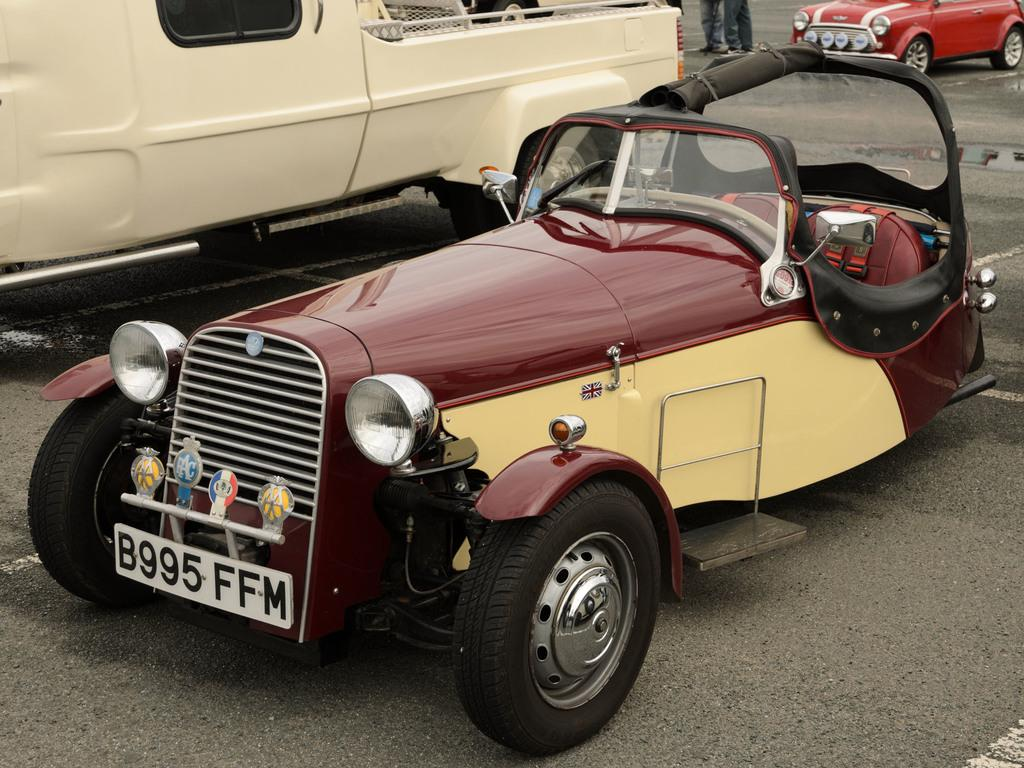What can be seen on the road in the image? There are vehicles on the road in the image. Can you describe the people in the image? The legs of persons are visible at the top of the image. Where is the faucet located in the image? There is no faucet present in the image. What type of event is taking place in the image? The image does not depict a specific event; it simply shows vehicles on the road and the legs of persons. 